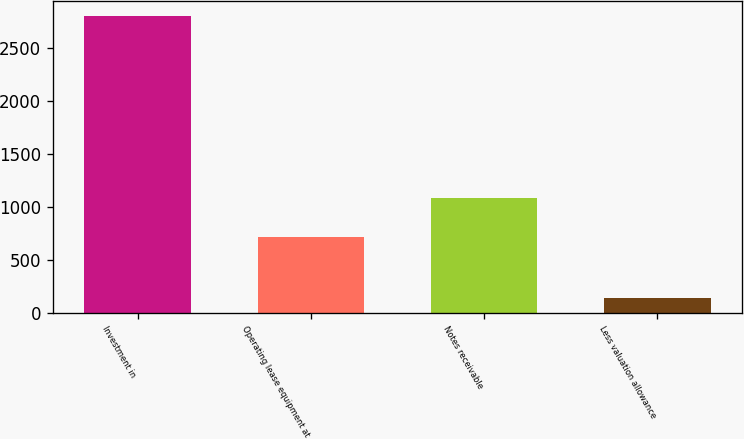Convert chart. <chart><loc_0><loc_0><loc_500><loc_500><bar_chart><fcel>Investment in<fcel>Operating lease equipment at<fcel>Notes receivable<fcel>Less valuation allowance<nl><fcel>2796<fcel>716<fcel>1086.1<fcel>142<nl></chart> 